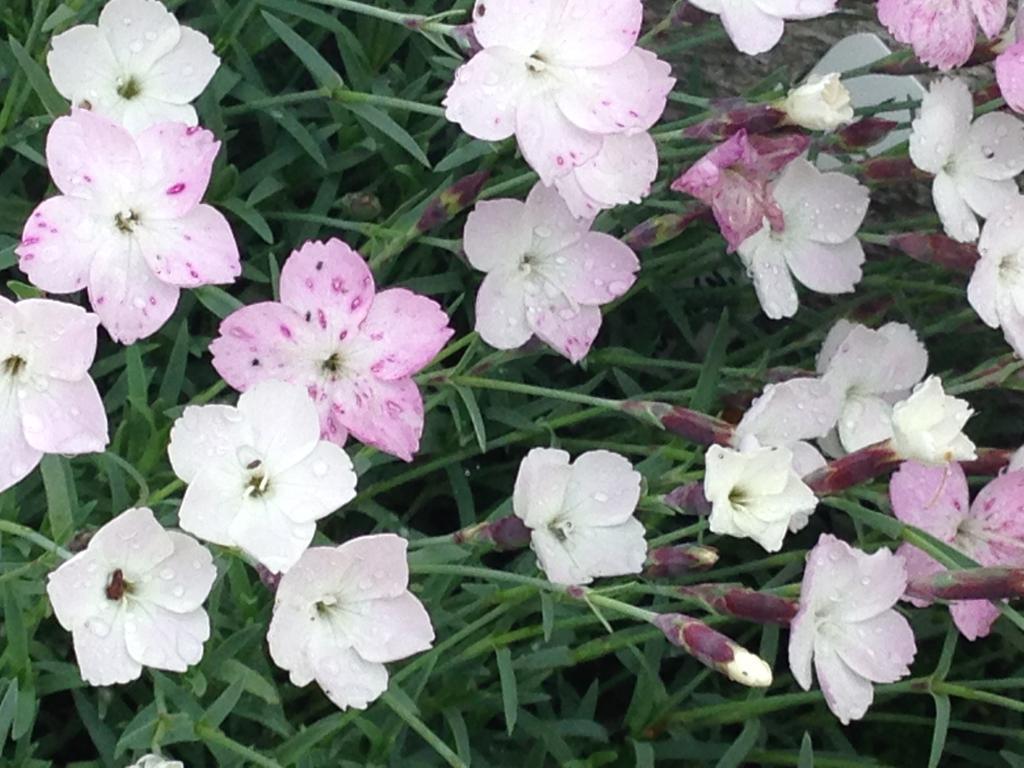Describe this image in one or two sentences. This image is taken outdoors. At the bottom of the image there is grass with beautiful flowers on the ground. Those flowers are pink in color. 